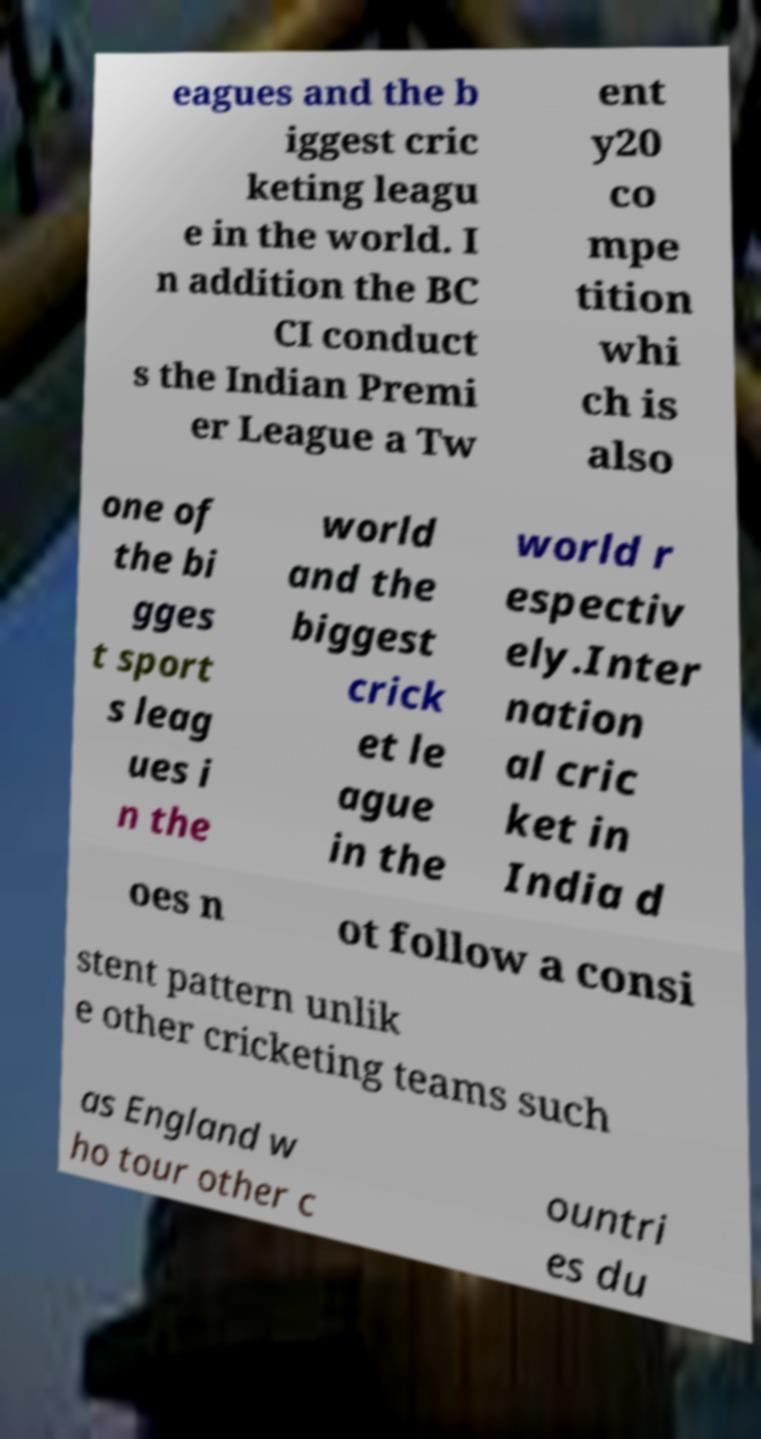Could you assist in decoding the text presented in this image and type it out clearly? eagues and the b iggest cric keting leagu e in the world. I n addition the BC CI conduct s the Indian Premi er League a Tw ent y20 co mpe tition whi ch is also one of the bi gges t sport s leag ues i n the world and the biggest crick et le ague in the world r espectiv ely.Inter nation al cric ket in India d oes n ot follow a consi stent pattern unlik e other cricketing teams such as England w ho tour other c ountri es du 